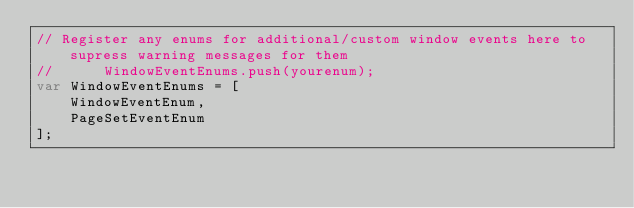<code> <loc_0><loc_0><loc_500><loc_500><_JavaScript_>// Register any enums for additional/custom window events here to supress warning messages for them
// 		WindowEventEnums.push(yourenum);
var WindowEventEnums = [
	WindowEventEnum,
	PageSetEventEnum
];</code> 